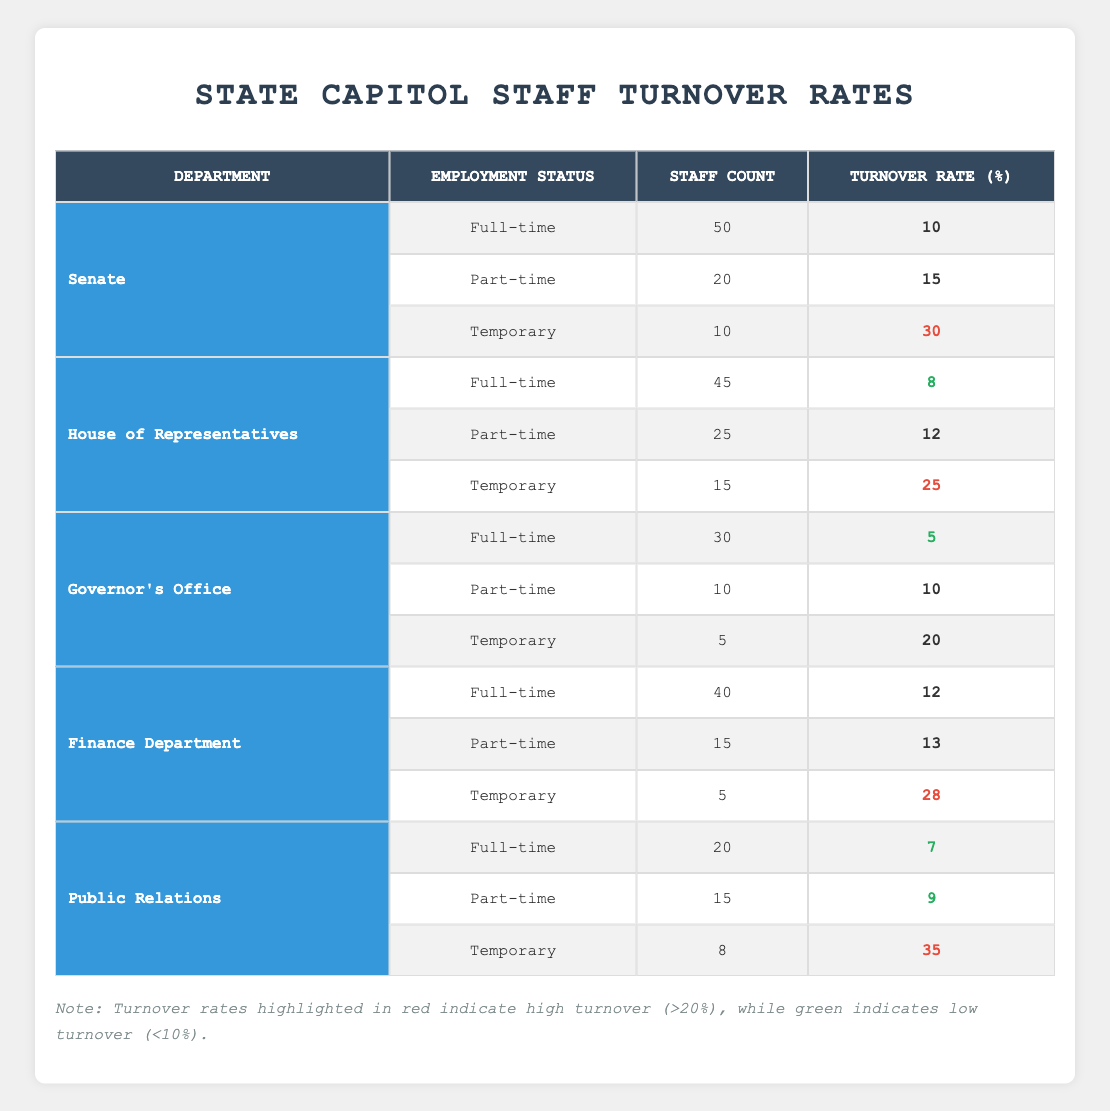What is the turnover rate for full-time staff in the Senate? The turnover rate for full-time staff in the Senate is listed directly in the table under the Senate's full-time row, which shows a turnover rate of 10%.
Answer: 10% How many part-time staff are there in the House of Representatives? The table shows the House of Representatives' part-time row with a staff count of 25.
Answer: 25 Which department has the highest turnover rate for temporary staff? By comparing the turnover rates for temporary staff across departments in the table, the Public Relations department has the highest turnover rate at 35%.
Answer: Public Relations What is the total staff count for the Senate? The staff count for the Senate is the sum of all its staff types: 50 (full-time) + 20 (part-time) + 10 (temporary) = 80.
Answer: 80 Is the turnover rate for part-time staff in the Finance Department less than that of part-time staff in the Governor's Office? In the table, the Finance Department has a part-time turnover rate of 13% and the Governor's Office has a part-time turnover rate of 10%. Since 13% is greater than 10%, the statement is false.
Answer: No What is the average turnover rate for full-time staff across all departments? The full-time turnover rates are: Senate (10%), House of Representatives (8%), Governor's Office (5%), Finance Department (12%), and Public Relations (7%). First, we sum these values: 10 + 8 + 5 + 12 + 7 = 42. Then, divide by the number of departments (5): 42/5 = 8.4.
Answer: 8.4 Which department has the lowest total turnover rate when considering all employment statuses? To find this, we calculate the total turnover rate for each department: Senate ((10 + 15 + 30)/3 = 18.33), House of Representatives ((8 + 12 + 25)/3 = 15), Governor's Office ((5 + 10 + 20)/3 = 11.67), Finance Department ((12 + 13 + 28)/3 = 17.67), Public Relations ((7 + 9 + 35)/3 = 17). The lowest average turnover rate is in the Governor's Office at 11.67%.
Answer: Governor's Office Is the turnover rate for full-time staff in the Finance Department greater than 10%? The table shows the turnover rate for full-time staff in the Finance Department is 12%, which is greater than 10%. Therefore, the statement is true.
Answer: Yes 